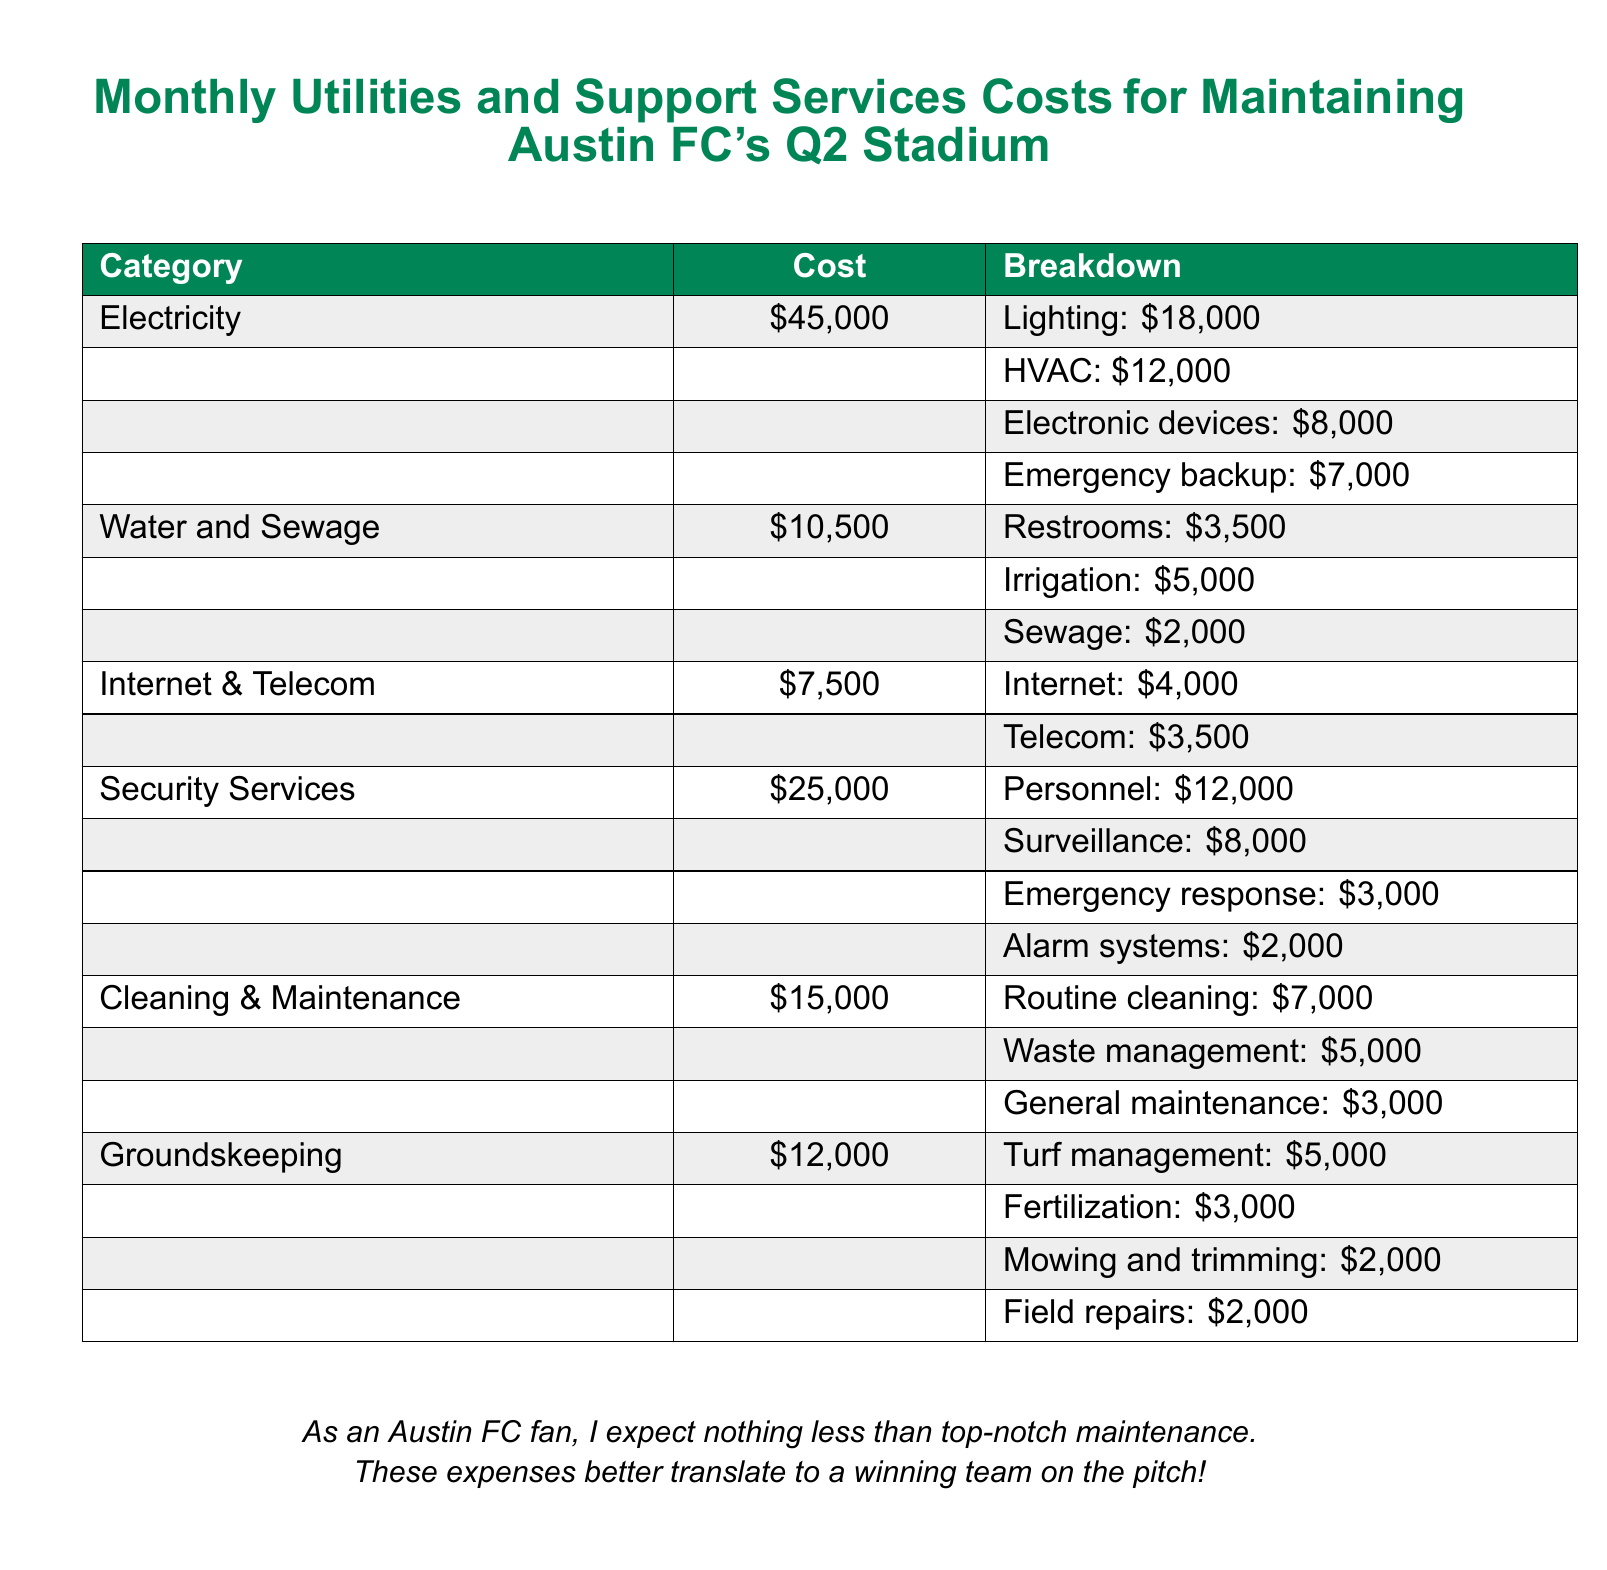what is the total cost of electricity? The total cost of electricity is provided in the table under the electricity category, which is $45,000.
Answer: $45,000 how much is spent on security services? The total amount spent on security services is listed as $25,000 in the document.
Answer: $25,000 what is the cost breakdown for water and sewage? The breakdown details for water and sewage can be found in the table, including restrooms, irrigation, and sewage for a total of $10,500.
Answer: $10,500 which category has the highest cost? By comparing the costs in the document, security services has the highest cost at $25,000.
Answer: Security Services how much is allocated for turf management? Turf management is specified in the groundskeeping section, costing $5,000.
Answer: $5,000 what percentage of the electricity cost is spent on HVAC? HVAC costs $12,000 out of the total electricity cost of $45,000, which is approximately 26.67%.
Answer: 26.67% how many components are listed under cleaning and maintenance? The cleaning and maintenance section details three components: routine cleaning, waste management, and general maintenance.
Answer: Three what is the total monthly expenditure on internet and telecom services? The document lists the total cost for internet and telecom services at $7,500.
Answer: $7,500 what is the total cost for groundskeeping? The sum of all components in the groundskeeping section amounts to $12,000.
Answer: $12,000 